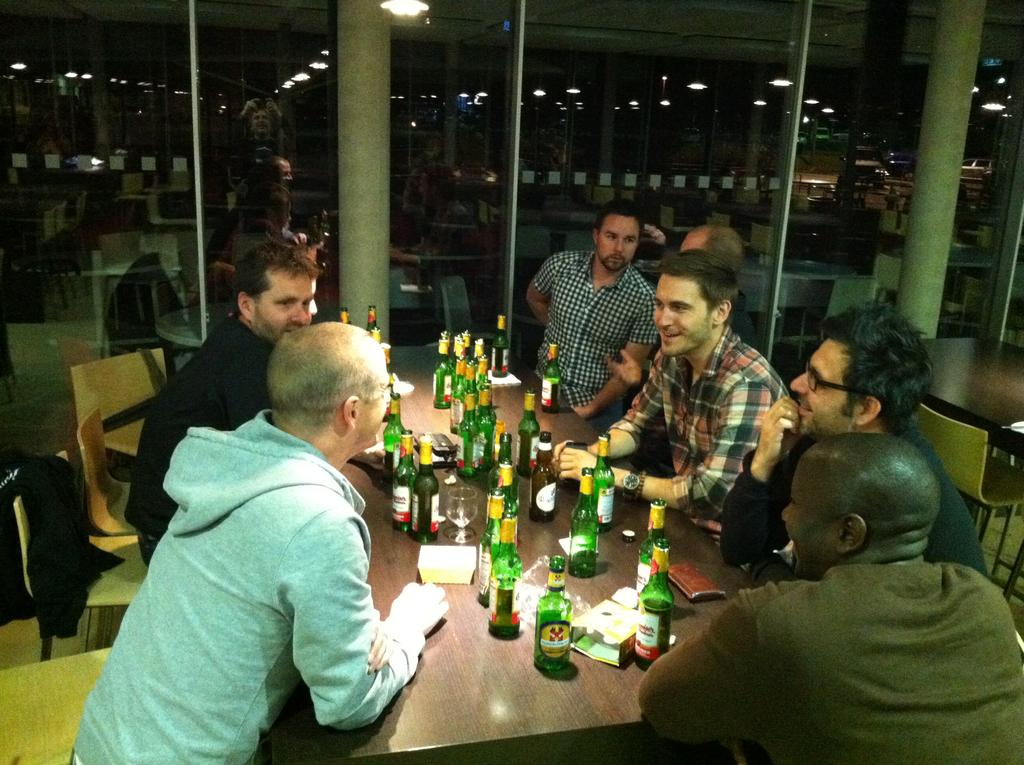What objects are on the table in the image? There are bottles, glasses, and papers on the table in the image. What are the people in the image doing? People are sitting on chairs around the table in the image. What can be seen in the background of the image? There is a glass wall and pillars in the background of the image. What type of riddle is being solved by the people in the image? There is no indication in the image that the people are solving a riddle. What company is hosting the event in the image? There is no company mentioned or visible in the image. 